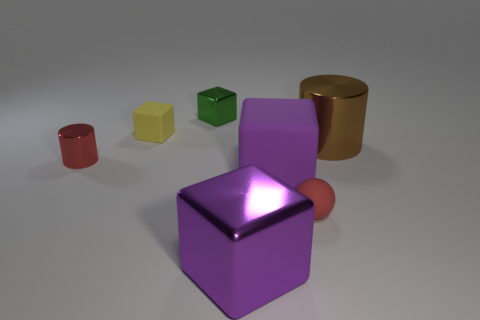Subtract 1 cubes. How many cubes are left? 3 Add 2 big yellow shiny objects. How many objects exist? 9 Subtract all gray blocks. Subtract all red cylinders. How many blocks are left? 4 Subtract all cylinders. How many objects are left? 5 Subtract 0 green spheres. How many objects are left? 7 Subtract all large shiny objects. Subtract all purple rubber blocks. How many objects are left? 4 Add 1 purple rubber things. How many purple rubber things are left? 2 Add 2 small yellow metallic objects. How many small yellow metallic objects exist? 2 